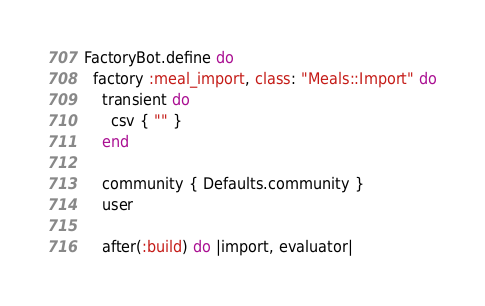<code> <loc_0><loc_0><loc_500><loc_500><_Ruby_>FactoryBot.define do
  factory :meal_import, class: "Meals::Import" do
    transient do
      csv { "" }
    end

    community { Defaults.community }
    user

    after(:build) do |import, evaluator|</code> 